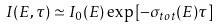<formula> <loc_0><loc_0><loc_500><loc_500>I ( E , \tau ) \simeq I _ { 0 } ( E ) \exp \left [ - \sigma _ { t o t } ( E ) \tau \right ]</formula> 